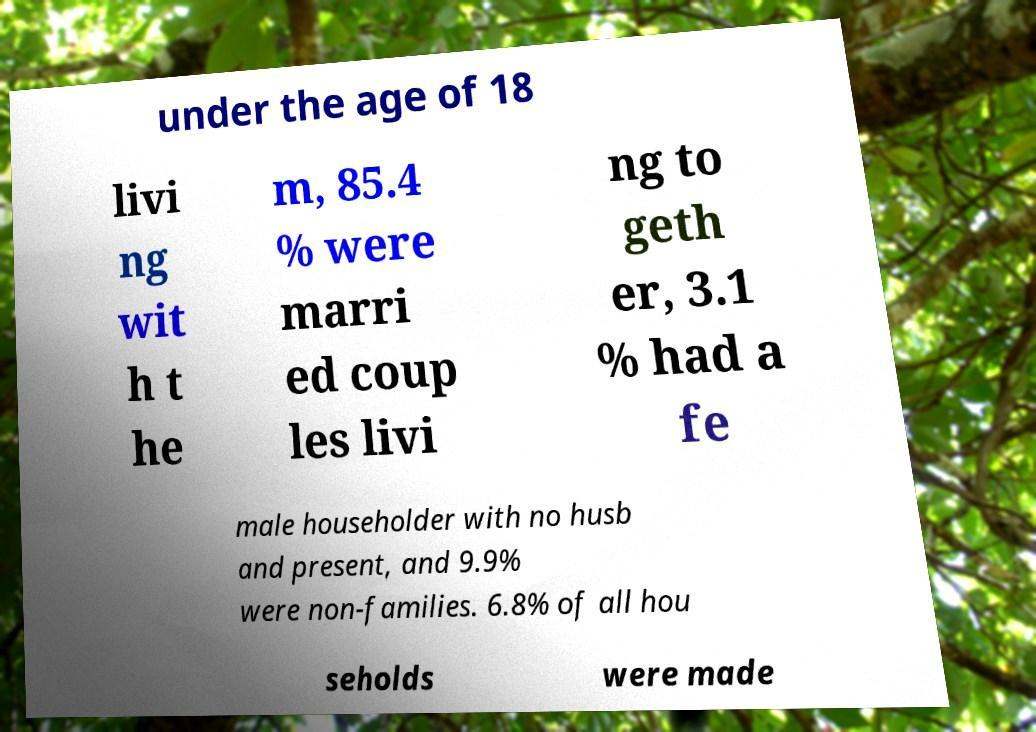For documentation purposes, I need the text within this image transcribed. Could you provide that? under the age of 18 livi ng wit h t he m, 85.4 % were marri ed coup les livi ng to geth er, 3.1 % had a fe male householder with no husb and present, and 9.9% were non-families. 6.8% of all hou seholds were made 